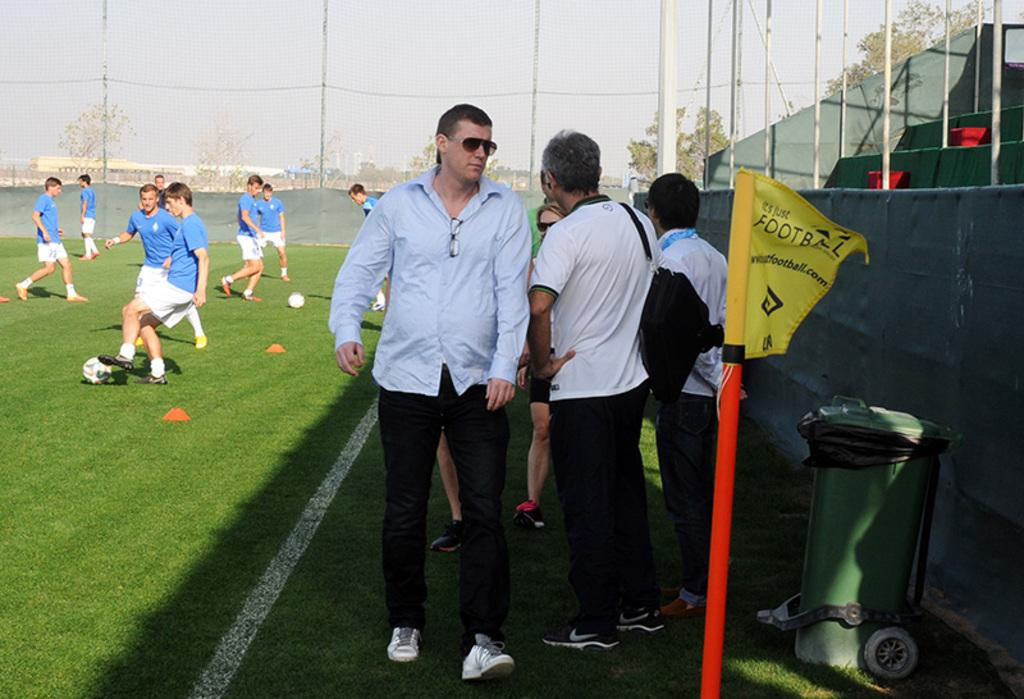What activity are the people in the image engaged in? The people in the image are playing football. Can you describe the person walking in front of the football players? There is a man walking in front of the football players. What can be seen in the background of the image? In the background of the image, there is a net, a flag, and a bin. What type of party is being held in the image? There is no party being held in the image; it shows people playing football and a man walking in front of them. How many men are playing football in the image? The number of men playing football cannot be determined from the image, as we only know that there are people playing football, but their gender is not specified. 